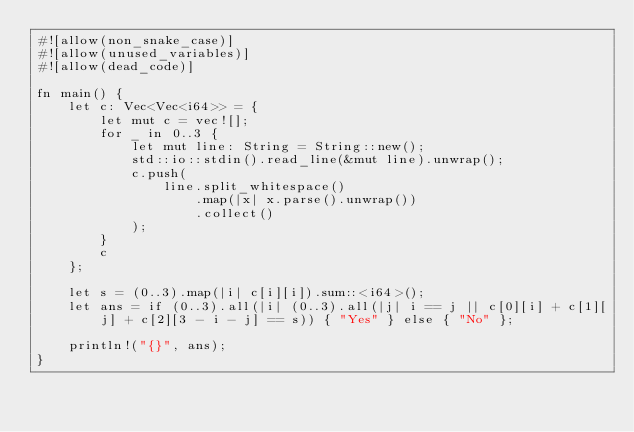<code> <loc_0><loc_0><loc_500><loc_500><_Rust_>#![allow(non_snake_case)]
#![allow(unused_variables)]
#![allow(dead_code)]

fn main() {
    let c: Vec<Vec<i64>> = {
        let mut c = vec![];
        for _ in 0..3 {
            let mut line: String = String::new();
            std::io::stdin().read_line(&mut line).unwrap();
            c.push(
                line.split_whitespace()
                    .map(|x| x.parse().unwrap())
                    .collect()
            );
        }
        c
    };

    let s = (0..3).map(|i| c[i][i]).sum::<i64>();
    let ans = if (0..3).all(|i| (0..3).all(|j| i == j || c[0][i] + c[1][j] + c[2][3 - i - j] == s)) { "Yes" } else { "No" };

    println!("{}", ans);
}</code> 